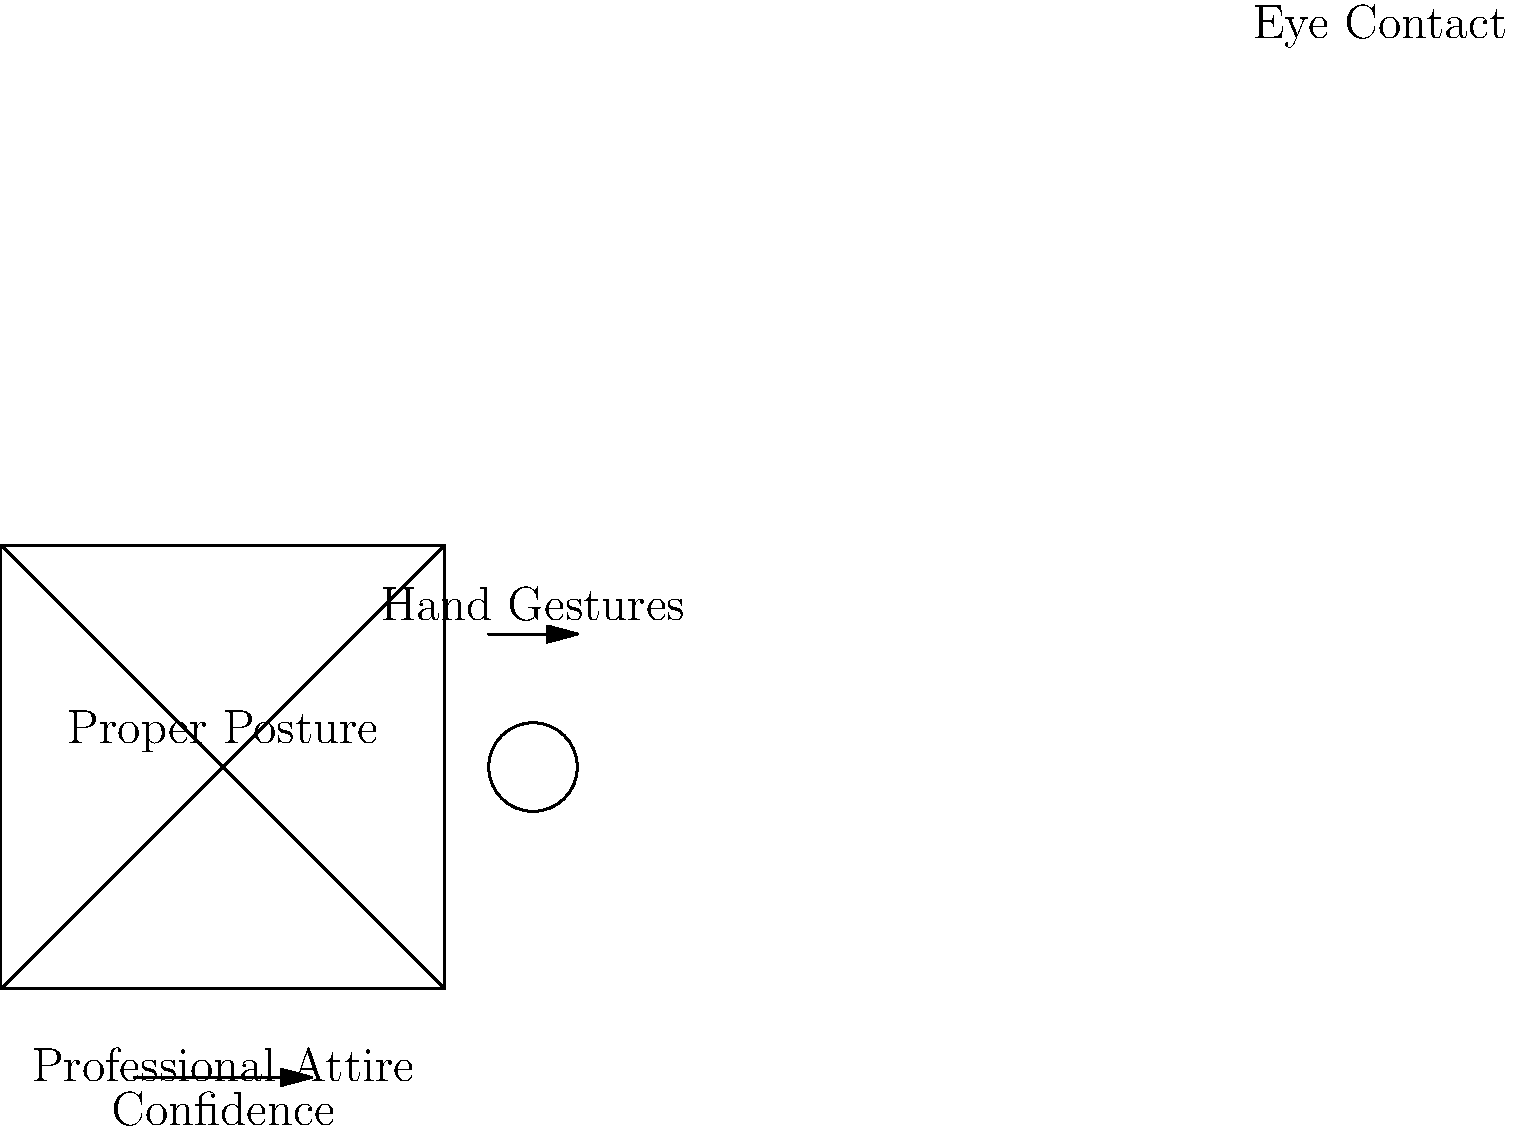In a moot court competition, which of the following elements is most crucial for maintaining a professional appearance and effective presentation, as illustrated in the diagram?

A) Eye contact
B) Hand gestures
C) Proper posture
D) Professional attire To excel in moot court competitions, all elements shown in the diagram are important. However, the most crucial element for maintaining a professional appearance and effective presentation is:

1. Proper posture: This is centrally located in the diagram, emphasizing its importance. Good posture projects confidence and professionalism.

2. Professional attire: While essential, it's secondary to posture in terms of immediate impact on the presentation.

3. Eye contact: This is crucial for engagement but is represented as a smaller element in the diagram.

4. Hand gestures: These can enhance communication but are less critical than posture for overall presentation.

5. Confidence: This is shown as an underlying factor, influenced by proper posture and attire.

The central position and prominence of "Proper Posture" in the diagram indicate its primary importance in maintaining a professional appearance and effective presentation during moot court competitions.
Answer: C) Proper posture 